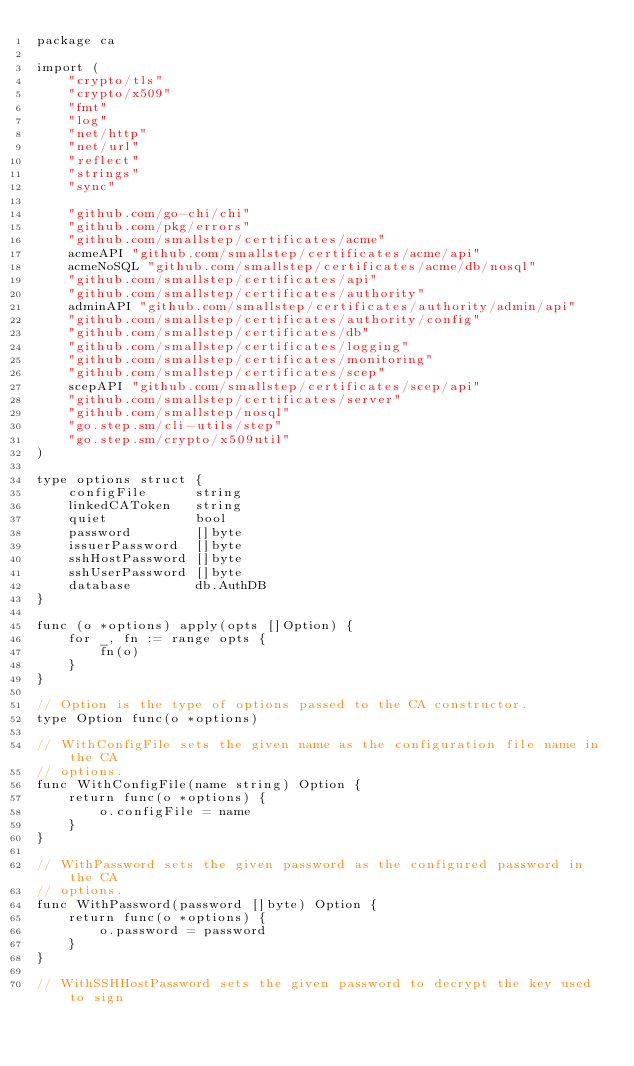Convert code to text. <code><loc_0><loc_0><loc_500><loc_500><_Go_>package ca

import (
	"crypto/tls"
	"crypto/x509"
	"fmt"
	"log"
	"net/http"
	"net/url"
	"reflect"
	"strings"
	"sync"

	"github.com/go-chi/chi"
	"github.com/pkg/errors"
	"github.com/smallstep/certificates/acme"
	acmeAPI "github.com/smallstep/certificates/acme/api"
	acmeNoSQL "github.com/smallstep/certificates/acme/db/nosql"
	"github.com/smallstep/certificates/api"
	"github.com/smallstep/certificates/authority"
	adminAPI "github.com/smallstep/certificates/authority/admin/api"
	"github.com/smallstep/certificates/authority/config"
	"github.com/smallstep/certificates/db"
	"github.com/smallstep/certificates/logging"
	"github.com/smallstep/certificates/monitoring"
	"github.com/smallstep/certificates/scep"
	scepAPI "github.com/smallstep/certificates/scep/api"
	"github.com/smallstep/certificates/server"
	"github.com/smallstep/nosql"
	"go.step.sm/cli-utils/step"
	"go.step.sm/crypto/x509util"
)

type options struct {
	configFile      string
	linkedCAToken   string
	quiet           bool
	password        []byte
	issuerPassword  []byte
	sshHostPassword []byte
	sshUserPassword []byte
	database        db.AuthDB
}

func (o *options) apply(opts []Option) {
	for _, fn := range opts {
		fn(o)
	}
}

// Option is the type of options passed to the CA constructor.
type Option func(o *options)

// WithConfigFile sets the given name as the configuration file name in the CA
// options.
func WithConfigFile(name string) Option {
	return func(o *options) {
		o.configFile = name
	}
}

// WithPassword sets the given password as the configured password in the CA
// options.
func WithPassword(password []byte) Option {
	return func(o *options) {
		o.password = password
	}
}

// WithSSHHostPassword sets the given password to decrypt the key used to sign</code> 